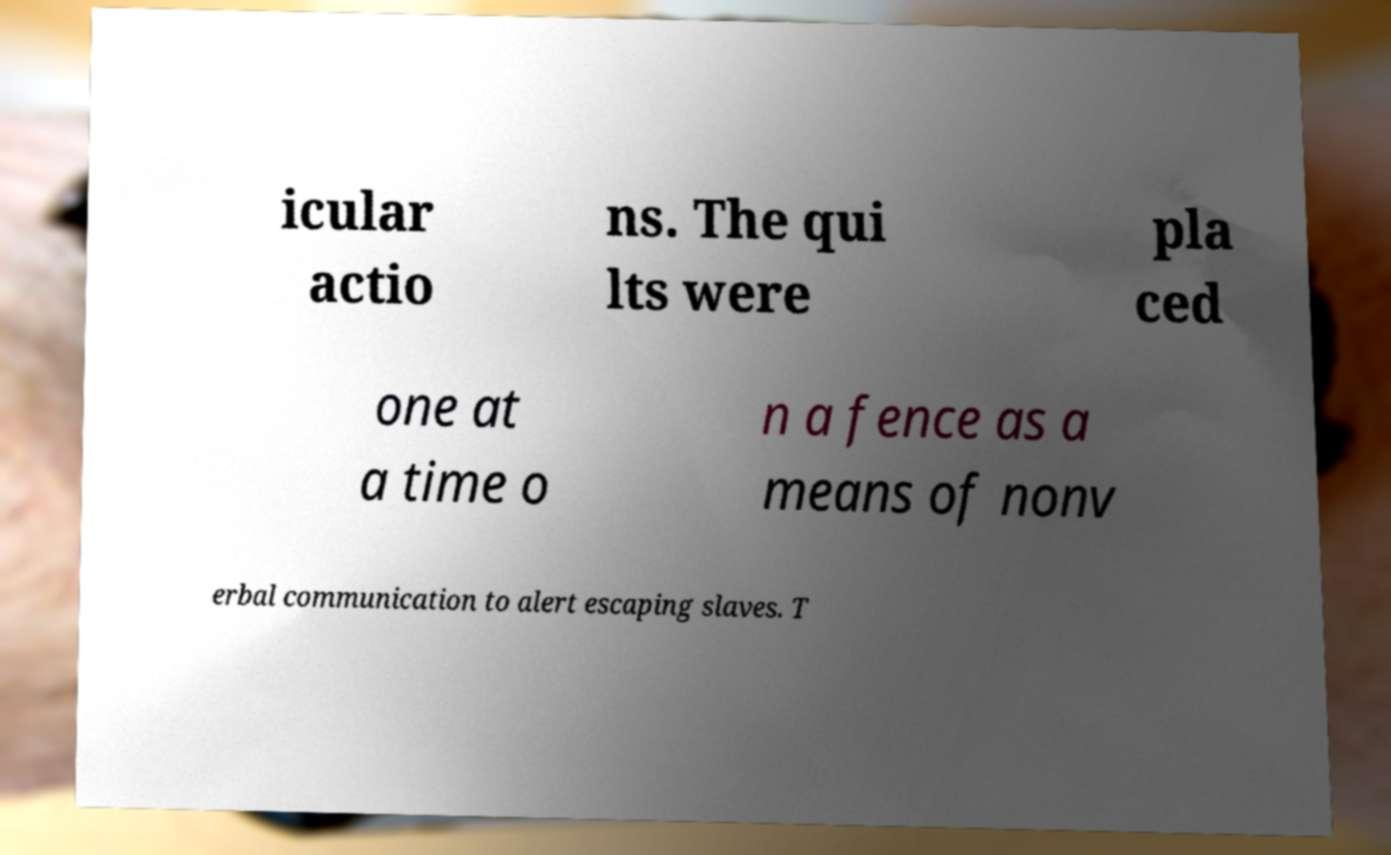There's text embedded in this image that I need extracted. Can you transcribe it verbatim? icular actio ns. The qui lts were pla ced one at a time o n a fence as a means of nonv erbal communication to alert escaping slaves. T 